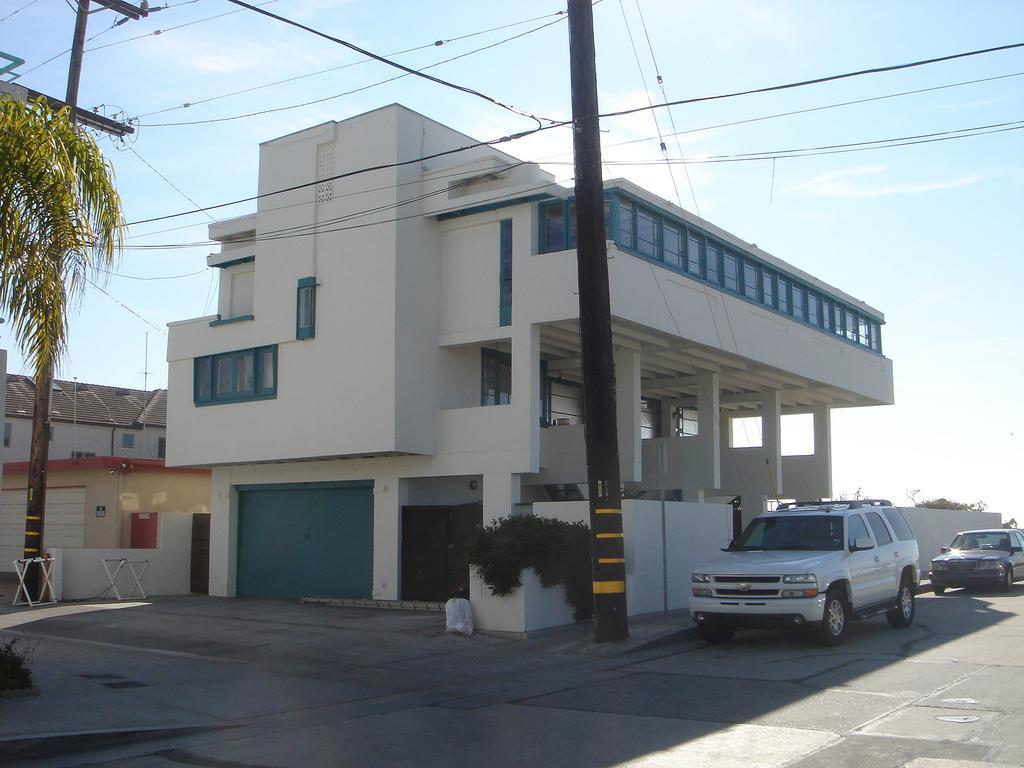Please provide a concise description of this image. In this image there are a few buildings and few vehicles are parked, in front of the buildings there are trees and utility poles. In the background there is the sky. 